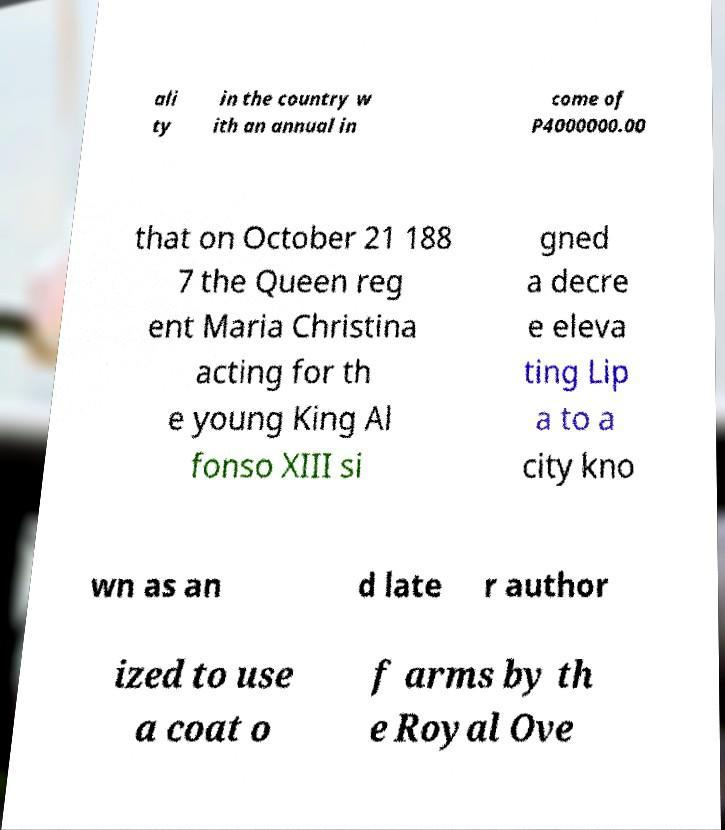There's text embedded in this image that I need extracted. Can you transcribe it verbatim? ali ty in the country w ith an annual in come of P4000000.00 that on October 21 188 7 the Queen reg ent Maria Christina acting for th e young King Al fonso XIII si gned a decre e eleva ting Lip a to a city kno wn as an d late r author ized to use a coat o f arms by th e Royal Ove 